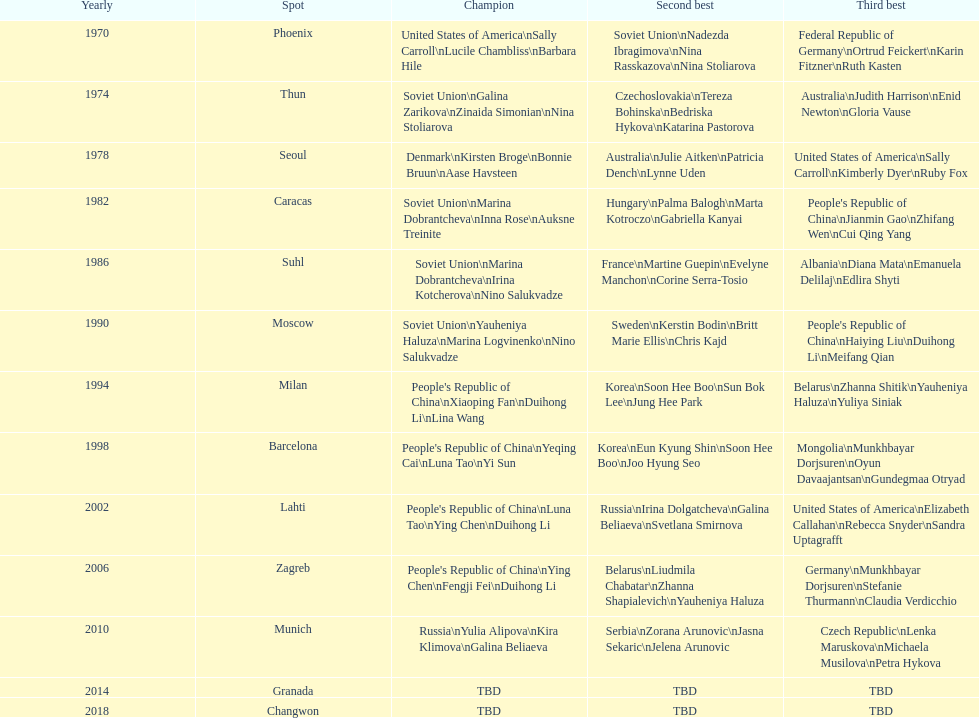What are the total number of times the soviet union is listed under the gold column? 4. 